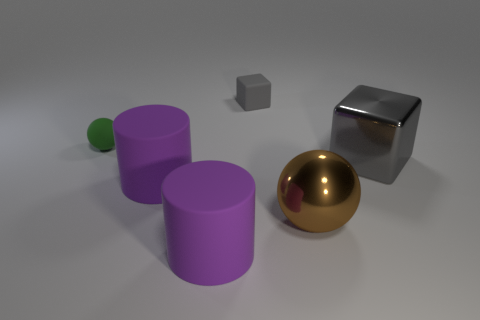The tiny rubber sphere that is behind the big shiny ball is what color?
Your answer should be very brief. Green. There is a matte thing that is behind the big gray object and to the right of the small green rubber ball; what size is it?
Provide a succinct answer. Small. Do the big gray object and the big cylinder behind the big brown metal object have the same material?
Keep it short and to the point. No. How many large purple objects are the same shape as the green matte thing?
Offer a very short reply. 0. There is another cube that is the same color as the big metallic block; what material is it?
Make the answer very short. Rubber. How many brown balls are there?
Give a very brief answer. 1. Do the green object and the large purple object in front of the large sphere have the same shape?
Your response must be concise. No. What number of objects are either blocks or objects that are in front of the tiny green ball?
Give a very brief answer. 5. There is a small object that is the same shape as the big gray metallic object; what material is it?
Make the answer very short. Rubber. Is the shape of the purple rubber thing that is behind the large brown ball the same as  the gray matte object?
Ensure brevity in your answer.  No. 